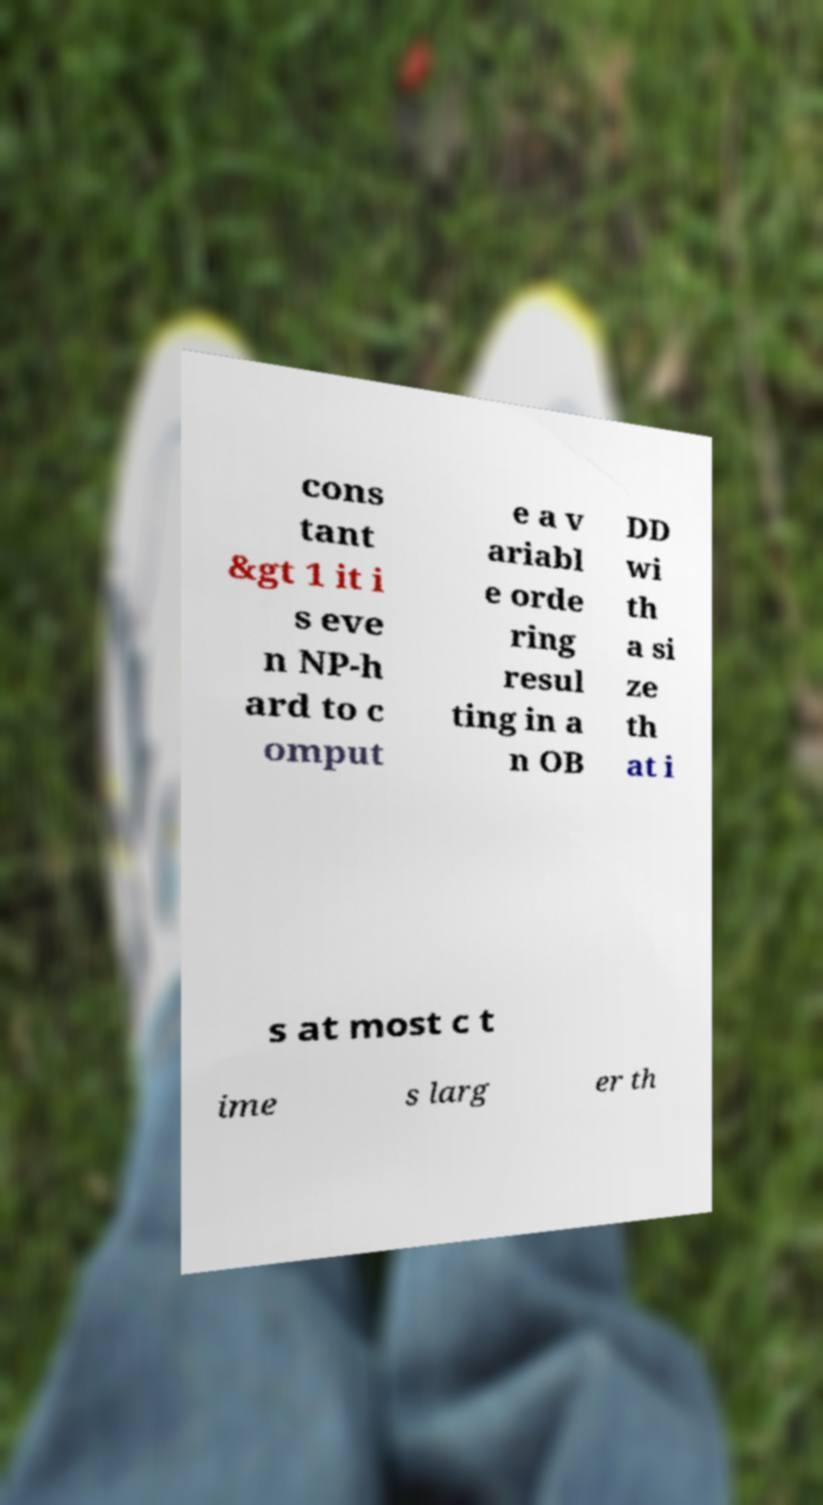Please identify and transcribe the text found in this image. cons tant &gt 1 it i s eve n NP-h ard to c omput e a v ariabl e orde ring resul ting in a n OB DD wi th a si ze th at i s at most c t ime s larg er th 